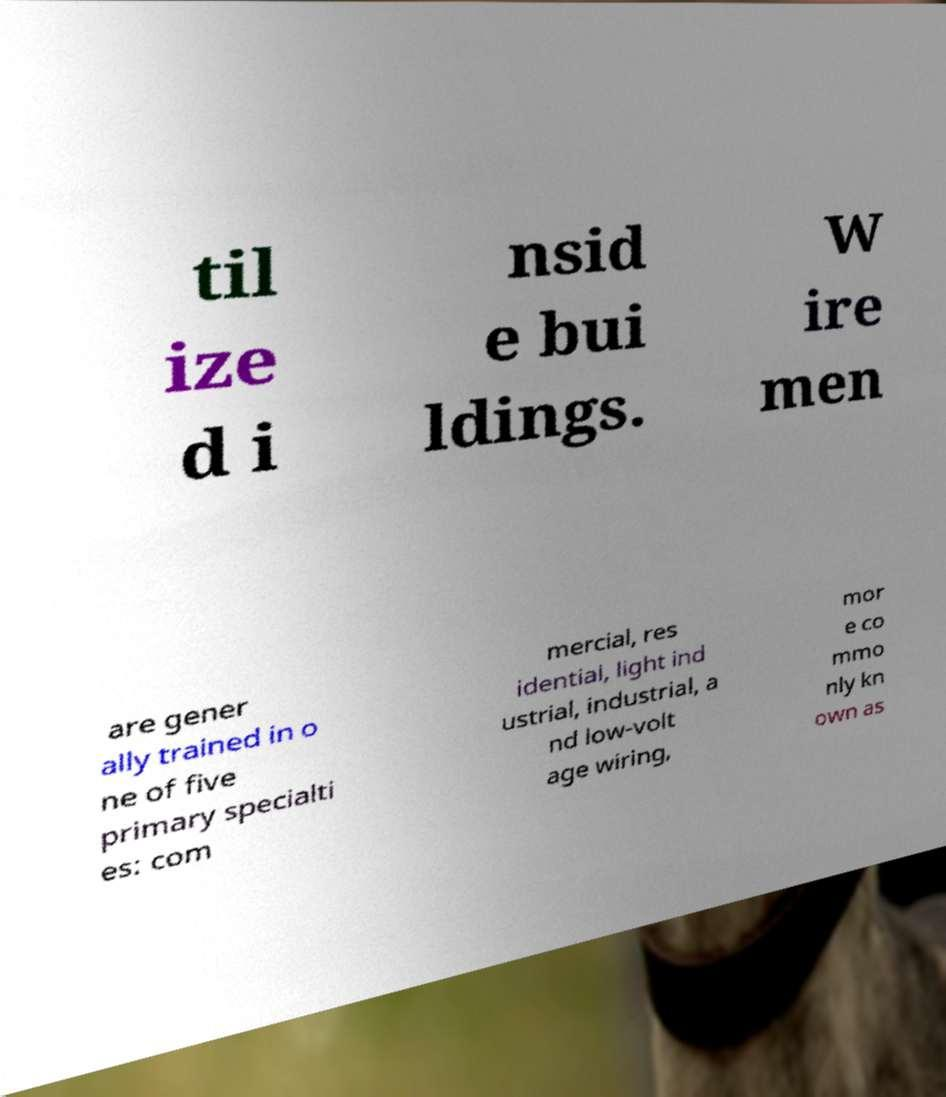Please identify and transcribe the text found in this image. til ize d i nsid e bui ldings. W ire men are gener ally trained in o ne of five primary specialti es: com mercial, res idential, light ind ustrial, industrial, a nd low-volt age wiring, mor e co mmo nly kn own as 